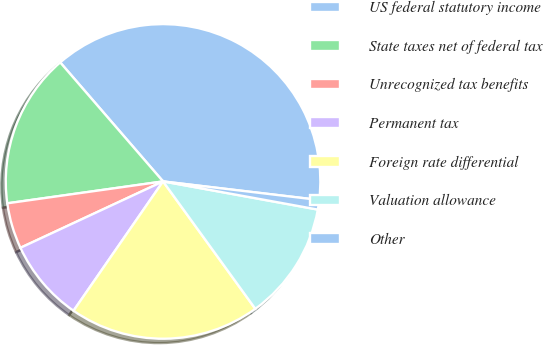<chart> <loc_0><loc_0><loc_500><loc_500><pie_chart><fcel>US federal statutory income<fcel>State taxes net of federal tax<fcel>Unrecognized tax benefits<fcel>Permanent tax<fcel>Foreign rate differential<fcel>Valuation allowance<fcel>Other<nl><fcel>38.23%<fcel>15.88%<fcel>4.71%<fcel>8.43%<fcel>19.61%<fcel>12.16%<fcel>0.98%<nl></chart> 